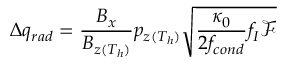Convert formula to latex. <formula><loc_0><loc_0><loc_500><loc_500>\Delta q _ { r a d } = \frac { B _ { x } } { B _ { z ( T _ { h } ) } } p _ { z ( T _ { h } ) } \sqrt { \frac { \kappa _ { 0 } } { 2 f _ { c o n d } } f _ { I } \mathcal { F } }</formula> 